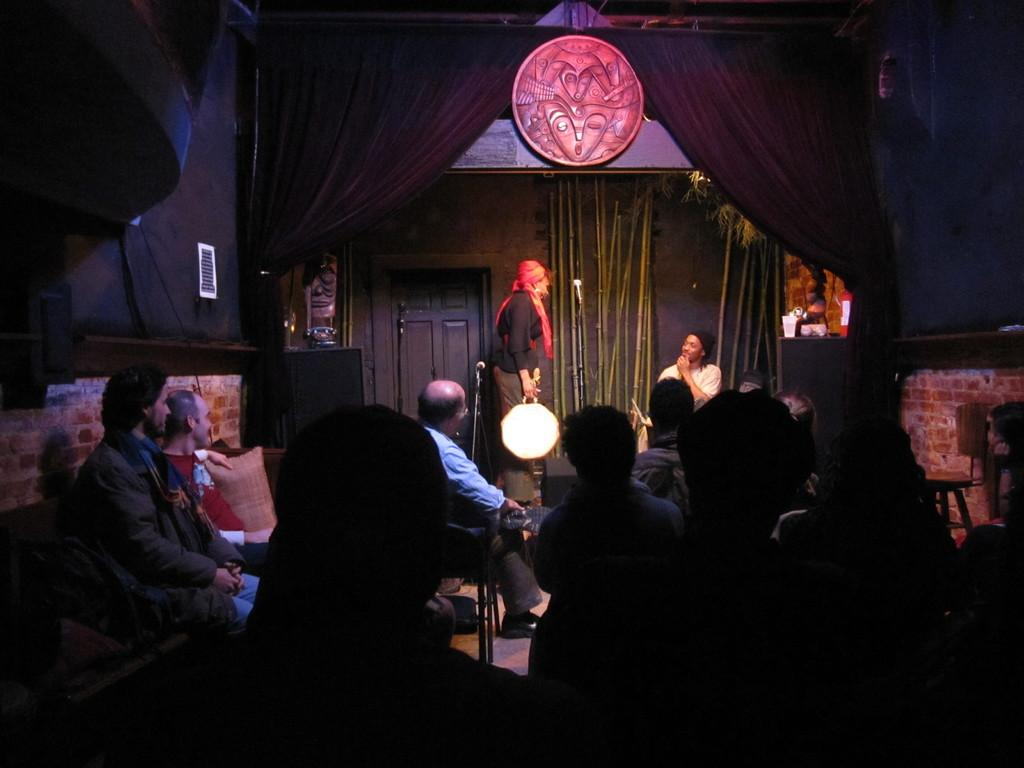What are the people in the front of the image doing? The people in the front of the image are sitting. What is happening in the background of the image? There is a small drama show happening in the background. How many actors are involved in the drama show? Two men are acting in the drama show. What is the color of the curtain above the drama show? There is a black curtain above the drama show. Where is the door located in the image? There is a door visible in the image. What type of list is being used as a veil in the image? There is no list or veil present in the image. What color is the curtain that is being used as a veil in the image? There is no curtain being used as a veil in the image. 